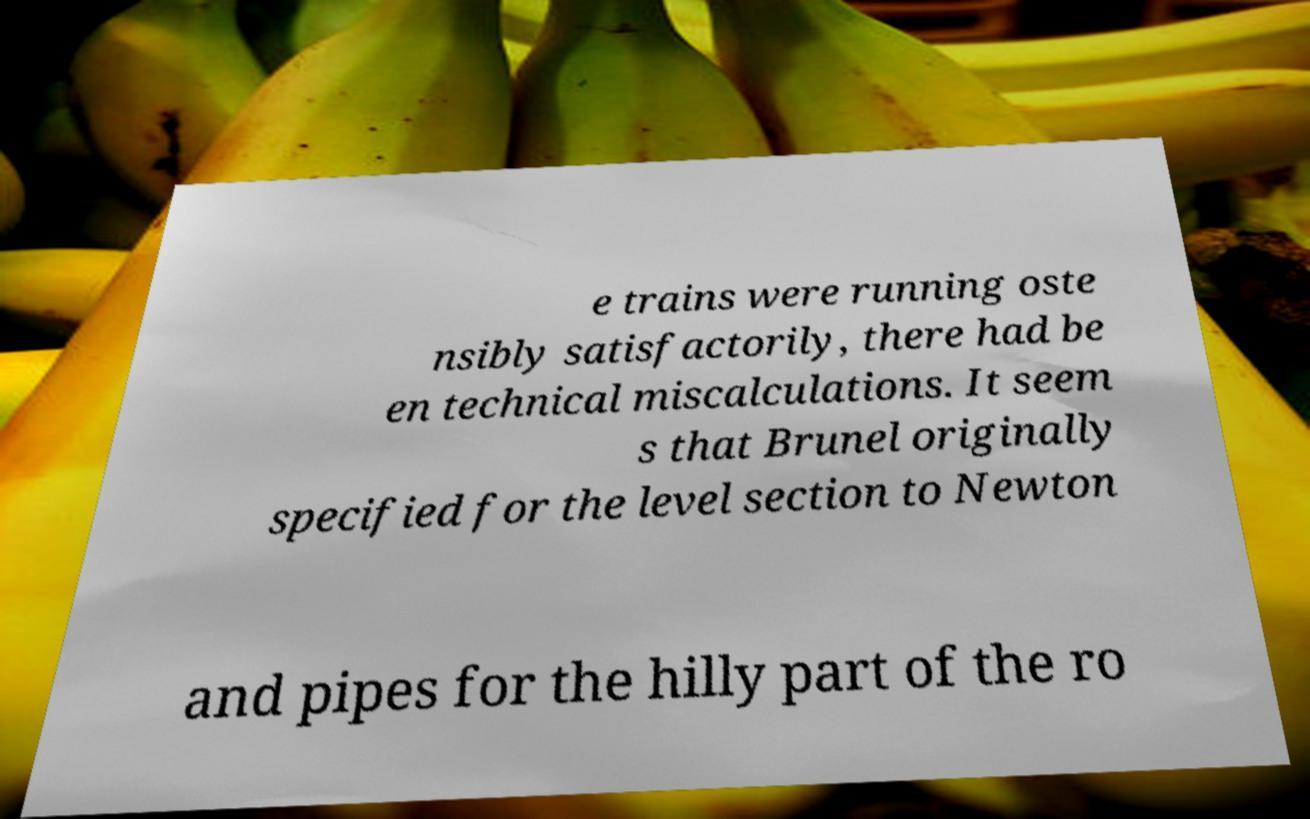Please read and relay the text visible in this image. What does it say? e trains were running oste nsibly satisfactorily, there had be en technical miscalculations. It seem s that Brunel originally specified for the level section to Newton and pipes for the hilly part of the ro 